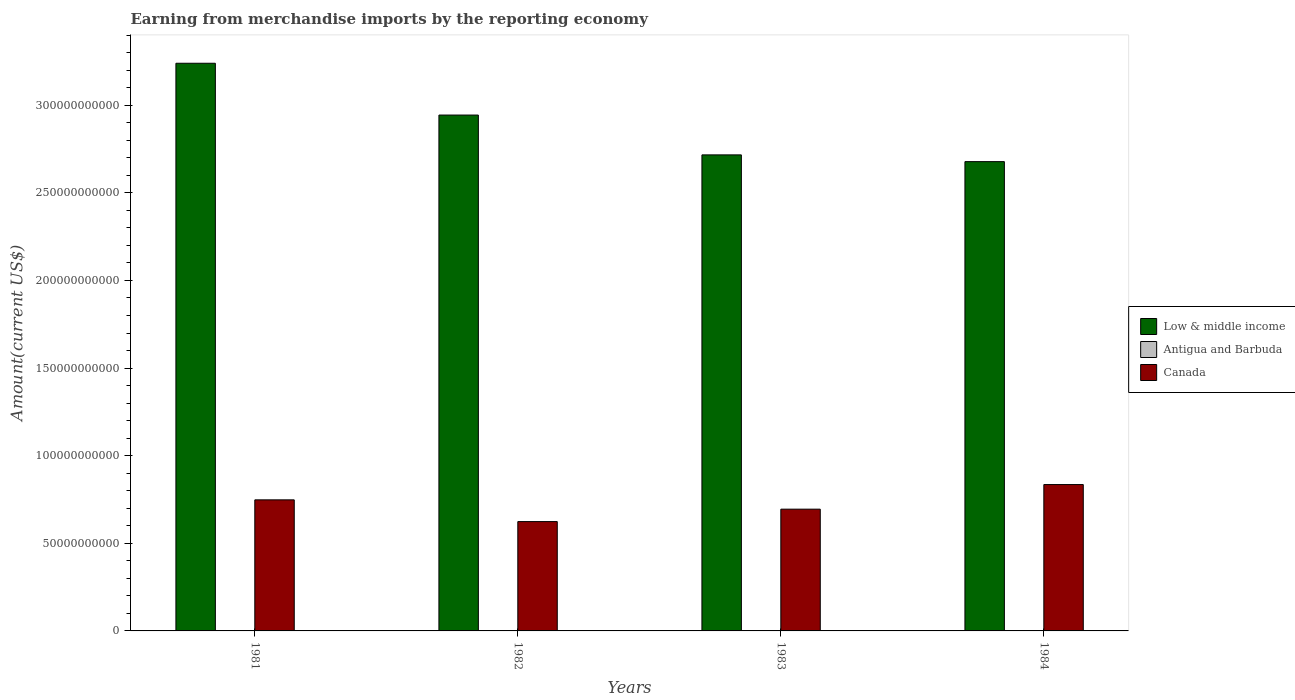How many different coloured bars are there?
Make the answer very short. 3. Are the number of bars per tick equal to the number of legend labels?
Your answer should be very brief. Yes. What is the label of the 2nd group of bars from the left?
Provide a succinct answer. 1982. What is the amount earned from merchandise imports in Canada in 1984?
Provide a short and direct response. 8.35e+1. Across all years, what is the maximum amount earned from merchandise imports in Antigua and Barbuda?
Offer a very short reply. 4.23e+07. Across all years, what is the minimum amount earned from merchandise imports in Low & middle income?
Offer a very short reply. 2.68e+11. In which year was the amount earned from merchandise imports in Low & middle income minimum?
Ensure brevity in your answer.  1984. What is the total amount earned from merchandise imports in Low & middle income in the graph?
Provide a succinct answer. 1.16e+12. What is the difference between the amount earned from merchandise imports in Low & middle income in 1981 and that in 1984?
Offer a very short reply. 5.61e+1. What is the difference between the amount earned from merchandise imports in Antigua and Barbuda in 1983 and the amount earned from merchandise imports in Low & middle income in 1984?
Keep it short and to the point. -2.68e+11. What is the average amount earned from merchandise imports in Antigua and Barbuda per year?
Your answer should be very brief. 3.02e+07. In the year 1981, what is the difference between the amount earned from merchandise imports in Antigua and Barbuda and amount earned from merchandise imports in Low & middle income?
Your answer should be very brief. -3.24e+11. In how many years, is the amount earned from merchandise imports in Canada greater than 70000000000 US$?
Keep it short and to the point. 2. What is the ratio of the amount earned from merchandise imports in Canada in 1981 to that in 1984?
Offer a very short reply. 0.9. What is the difference between the highest and the second highest amount earned from merchandise imports in Low & middle income?
Make the answer very short. 2.96e+1. What is the difference between the highest and the lowest amount earned from merchandise imports in Antigua and Barbuda?
Offer a very short reply. 2.06e+07. In how many years, is the amount earned from merchandise imports in Antigua and Barbuda greater than the average amount earned from merchandise imports in Antigua and Barbuda taken over all years?
Offer a very short reply. 2. What does the 2nd bar from the left in 1984 represents?
Ensure brevity in your answer.  Antigua and Barbuda. What does the 2nd bar from the right in 1982 represents?
Provide a succinct answer. Antigua and Barbuda. Is it the case that in every year, the sum of the amount earned from merchandise imports in Canada and amount earned from merchandise imports in Antigua and Barbuda is greater than the amount earned from merchandise imports in Low & middle income?
Provide a short and direct response. No. Are all the bars in the graph horizontal?
Your answer should be compact. No. Does the graph contain grids?
Your answer should be compact. No. Where does the legend appear in the graph?
Offer a very short reply. Center right. How many legend labels are there?
Ensure brevity in your answer.  3. How are the legend labels stacked?
Provide a short and direct response. Vertical. What is the title of the graph?
Provide a short and direct response. Earning from merchandise imports by the reporting economy. What is the label or title of the Y-axis?
Offer a very short reply. Amount(current US$). What is the Amount(current US$) in Low & middle income in 1981?
Your answer should be compact. 3.24e+11. What is the Amount(current US$) of Antigua and Barbuda in 1981?
Offer a very short reply. 2.17e+07. What is the Amount(current US$) of Canada in 1981?
Keep it short and to the point. 7.48e+1. What is the Amount(current US$) in Low & middle income in 1982?
Make the answer very short. 2.94e+11. What is the Amount(current US$) of Antigua and Barbuda in 1982?
Keep it short and to the point. 3.05e+07. What is the Amount(current US$) of Canada in 1982?
Your response must be concise. 6.24e+1. What is the Amount(current US$) of Low & middle income in 1983?
Offer a terse response. 2.72e+11. What is the Amount(current US$) in Antigua and Barbuda in 1983?
Offer a terse response. 2.64e+07. What is the Amount(current US$) in Canada in 1983?
Keep it short and to the point. 6.95e+1. What is the Amount(current US$) of Low & middle income in 1984?
Provide a succinct answer. 2.68e+11. What is the Amount(current US$) in Antigua and Barbuda in 1984?
Your answer should be very brief. 4.23e+07. What is the Amount(current US$) in Canada in 1984?
Ensure brevity in your answer.  8.35e+1. Across all years, what is the maximum Amount(current US$) of Low & middle income?
Your response must be concise. 3.24e+11. Across all years, what is the maximum Amount(current US$) in Antigua and Barbuda?
Your response must be concise. 4.23e+07. Across all years, what is the maximum Amount(current US$) of Canada?
Your answer should be very brief. 8.35e+1. Across all years, what is the minimum Amount(current US$) of Low & middle income?
Offer a very short reply. 2.68e+11. Across all years, what is the minimum Amount(current US$) in Antigua and Barbuda?
Your response must be concise. 2.17e+07. Across all years, what is the minimum Amount(current US$) in Canada?
Ensure brevity in your answer.  6.24e+1. What is the total Amount(current US$) of Low & middle income in the graph?
Make the answer very short. 1.16e+12. What is the total Amount(current US$) of Antigua and Barbuda in the graph?
Offer a terse response. 1.21e+08. What is the total Amount(current US$) of Canada in the graph?
Your answer should be very brief. 2.90e+11. What is the difference between the Amount(current US$) in Low & middle income in 1981 and that in 1982?
Ensure brevity in your answer.  2.96e+1. What is the difference between the Amount(current US$) of Antigua and Barbuda in 1981 and that in 1982?
Provide a short and direct response. -8.81e+06. What is the difference between the Amount(current US$) in Canada in 1981 and that in 1982?
Your response must be concise. 1.24e+1. What is the difference between the Amount(current US$) of Low & middle income in 1981 and that in 1983?
Provide a short and direct response. 5.23e+1. What is the difference between the Amount(current US$) of Antigua and Barbuda in 1981 and that in 1983?
Your answer should be very brief. -4.69e+06. What is the difference between the Amount(current US$) in Canada in 1981 and that in 1983?
Give a very brief answer. 5.31e+09. What is the difference between the Amount(current US$) of Low & middle income in 1981 and that in 1984?
Offer a very short reply. 5.61e+1. What is the difference between the Amount(current US$) in Antigua and Barbuda in 1981 and that in 1984?
Offer a very short reply. -2.06e+07. What is the difference between the Amount(current US$) in Canada in 1981 and that in 1984?
Provide a succinct answer. -8.73e+09. What is the difference between the Amount(current US$) of Low & middle income in 1982 and that in 1983?
Your answer should be compact. 2.27e+1. What is the difference between the Amount(current US$) of Antigua and Barbuda in 1982 and that in 1983?
Your response must be concise. 4.12e+06. What is the difference between the Amount(current US$) of Canada in 1982 and that in 1983?
Make the answer very short. -7.09e+09. What is the difference between the Amount(current US$) in Low & middle income in 1982 and that in 1984?
Keep it short and to the point. 2.66e+1. What is the difference between the Amount(current US$) of Antigua and Barbuda in 1982 and that in 1984?
Offer a terse response. -1.18e+07. What is the difference between the Amount(current US$) in Canada in 1982 and that in 1984?
Keep it short and to the point. -2.11e+1. What is the difference between the Amount(current US$) in Low & middle income in 1983 and that in 1984?
Ensure brevity in your answer.  3.85e+09. What is the difference between the Amount(current US$) in Antigua and Barbuda in 1983 and that in 1984?
Your response must be concise. -1.59e+07. What is the difference between the Amount(current US$) in Canada in 1983 and that in 1984?
Your answer should be compact. -1.40e+1. What is the difference between the Amount(current US$) of Low & middle income in 1981 and the Amount(current US$) of Antigua and Barbuda in 1982?
Provide a succinct answer. 3.24e+11. What is the difference between the Amount(current US$) in Low & middle income in 1981 and the Amount(current US$) in Canada in 1982?
Make the answer very short. 2.62e+11. What is the difference between the Amount(current US$) of Antigua and Barbuda in 1981 and the Amount(current US$) of Canada in 1982?
Offer a terse response. -6.24e+1. What is the difference between the Amount(current US$) of Low & middle income in 1981 and the Amount(current US$) of Antigua and Barbuda in 1983?
Your answer should be compact. 3.24e+11. What is the difference between the Amount(current US$) in Low & middle income in 1981 and the Amount(current US$) in Canada in 1983?
Provide a short and direct response. 2.54e+11. What is the difference between the Amount(current US$) in Antigua and Barbuda in 1981 and the Amount(current US$) in Canada in 1983?
Give a very brief answer. -6.95e+1. What is the difference between the Amount(current US$) in Low & middle income in 1981 and the Amount(current US$) in Antigua and Barbuda in 1984?
Your response must be concise. 3.24e+11. What is the difference between the Amount(current US$) of Low & middle income in 1981 and the Amount(current US$) of Canada in 1984?
Your answer should be very brief. 2.40e+11. What is the difference between the Amount(current US$) of Antigua and Barbuda in 1981 and the Amount(current US$) of Canada in 1984?
Your response must be concise. -8.35e+1. What is the difference between the Amount(current US$) of Low & middle income in 1982 and the Amount(current US$) of Antigua and Barbuda in 1983?
Your answer should be compact. 2.94e+11. What is the difference between the Amount(current US$) of Low & middle income in 1982 and the Amount(current US$) of Canada in 1983?
Provide a succinct answer. 2.25e+11. What is the difference between the Amount(current US$) of Antigua and Barbuda in 1982 and the Amount(current US$) of Canada in 1983?
Provide a succinct answer. -6.95e+1. What is the difference between the Amount(current US$) in Low & middle income in 1982 and the Amount(current US$) in Antigua and Barbuda in 1984?
Ensure brevity in your answer.  2.94e+11. What is the difference between the Amount(current US$) of Low & middle income in 1982 and the Amount(current US$) of Canada in 1984?
Make the answer very short. 2.11e+11. What is the difference between the Amount(current US$) in Antigua and Barbuda in 1982 and the Amount(current US$) in Canada in 1984?
Provide a succinct answer. -8.35e+1. What is the difference between the Amount(current US$) of Low & middle income in 1983 and the Amount(current US$) of Antigua and Barbuda in 1984?
Make the answer very short. 2.72e+11. What is the difference between the Amount(current US$) in Low & middle income in 1983 and the Amount(current US$) in Canada in 1984?
Offer a terse response. 1.88e+11. What is the difference between the Amount(current US$) in Antigua and Barbuda in 1983 and the Amount(current US$) in Canada in 1984?
Provide a succinct answer. -8.35e+1. What is the average Amount(current US$) in Low & middle income per year?
Give a very brief answer. 2.89e+11. What is the average Amount(current US$) of Antigua and Barbuda per year?
Provide a short and direct response. 3.02e+07. What is the average Amount(current US$) in Canada per year?
Offer a very short reply. 7.25e+1. In the year 1981, what is the difference between the Amount(current US$) in Low & middle income and Amount(current US$) in Antigua and Barbuda?
Provide a succinct answer. 3.24e+11. In the year 1981, what is the difference between the Amount(current US$) in Low & middle income and Amount(current US$) in Canada?
Provide a succinct answer. 2.49e+11. In the year 1981, what is the difference between the Amount(current US$) in Antigua and Barbuda and Amount(current US$) in Canada?
Offer a terse response. -7.48e+1. In the year 1982, what is the difference between the Amount(current US$) of Low & middle income and Amount(current US$) of Antigua and Barbuda?
Give a very brief answer. 2.94e+11. In the year 1982, what is the difference between the Amount(current US$) of Low & middle income and Amount(current US$) of Canada?
Offer a terse response. 2.32e+11. In the year 1982, what is the difference between the Amount(current US$) in Antigua and Barbuda and Amount(current US$) in Canada?
Keep it short and to the point. -6.24e+1. In the year 1983, what is the difference between the Amount(current US$) of Low & middle income and Amount(current US$) of Antigua and Barbuda?
Provide a succinct answer. 2.72e+11. In the year 1983, what is the difference between the Amount(current US$) of Low & middle income and Amount(current US$) of Canada?
Your answer should be very brief. 2.02e+11. In the year 1983, what is the difference between the Amount(current US$) in Antigua and Barbuda and Amount(current US$) in Canada?
Your response must be concise. -6.95e+1. In the year 1984, what is the difference between the Amount(current US$) in Low & middle income and Amount(current US$) in Antigua and Barbuda?
Provide a succinct answer. 2.68e+11. In the year 1984, what is the difference between the Amount(current US$) of Low & middle income and Amount(current US$) of Canada?
Ensure brevity in your answer.  1.84e+11. In the year 1984, what is the difference between the Amount(current US$) of Antigua and Barbuda and Amount(current US$) of Canada?
Give a very brief answer. -8.35e+1. What is the ratio of the Amount(current US$) in Low & middle income in 1981 to that in 1982?
Your answer should be very brief. 1.1. What is the ratio of the Amount(current US$) in Antigua and Barbuda in 1981 to that in 1982?
Ensure brevity in your answer.  0.71. What is the ratio of the Amount(current US$) of Canada in 1981 to that in 1982?
Offer a very short reply. 1.2. What is the ratio of the Amount(current US$) in Low & middle income in 1981 to that in 1983?
Ensure brevity in your answer.  1.19. What is the ratio of the Amount(current US$) in Antigua and Barbuda in 1981 to that in 1983?
Give a very brief answer. 0.82. What is the ratio of the Amount(current US$) in Canada in 1981 to that in 1983?
Provide a short and direct response. 1.08. What is the ratio of the Amount(current US$) of Low & middle income in 1981 to that in 1984?
Offer a very short reply. 1.21. What is the ratio of the Amount(current US$) in Antigua and Barbuda in 1981 to that in 1984?
Provide a short and direct response. 0.51. What is the ratio of the Amount(current US$) of Canada in 1981 to that in 1984?
Keep it short and to the point. 0.9. What is the ratio of the Amount(current US$) in Low & middle income in 1982 to that in 1983?
Give a very brief answer. 1.08. What is the ratio of the Amount(current US$) of Antigua and Barbuda in 1982 to that in 1983?
Make the answer very short. 1.16. What is the ratio of the Amount(current US$) in Canada in 1982 to that in 1983?
Provide a short and direct response. 0.9. What is the ratio of the Amount(current US$) of Low & middle income in 1982 to that in 1984?
Your response must be concise. 1.1. What is the ratio of the Amount(current US$) in Antigua and Barbuda in 1982 to that in 1984?
Provide a short and direct response. 0.72. What is the ratio of the Amount(current US$) in Canada in 1982 to that in 1984?
Offer a terse response. 0.75. What is the ratio of the Amount(current US$) of Low & middle income in 1983 to that in 1984?
Keep it short and to the point. 1.01. What is the ratio of the Amount(current US$) of Antigua and Barbuda in 1983 to that in 1984?
Give a very brief answer. 0.62. What is the ratio of the Amount(current US$) in Canada in 1983 to that in 1984?
Provide a short and direct response. 0.83. What is the difference between the highest and the second highest Amount(current US$) in Low & middle income?
Your answer should be compact. 2.96e+1. What is the difference between the highest and the second highest Amount(current US$) in Antigua and Barbuda?
Offer a terse response. 1.18e+07. What is the difference between the highest and the second highest Amount(current US$) in Canada?
Your response must be concise. 8.73e+09. What is the difference between the highest and the lowest Amount(current US$) of Low & middle income?
Your answer should be compact. 5.61e+1. What is the difference between the highest and the lowest Amount(current US$) in Antigua and Barbuda?
Give a very brief answer. 2.06e+07. What is the difference between the highest and the lowest Amount(current US$) of Canada?
Your response must be concise. 2.11e+1. 